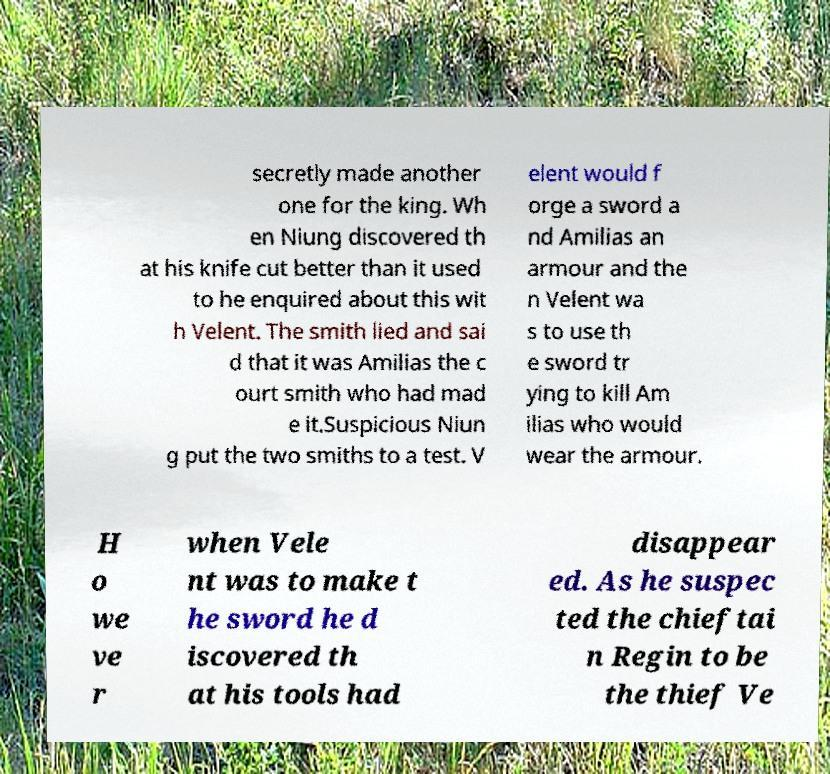Please read and relay the text visible in this image. What does it say? secretly made another one for the king. Wh en Niung discovered th at his knife cut better than it used to he enquired about this wit h Velent. The smith lied and sai d that it was Amilias the c ourt smith who had mad e it.Suspicious Niun g put the two smiths to a test. V elent would f orge a sword a nd Amilias an armour and the n Velent wa s to use th e sword tr ying to kill Am ilias who would wear the armour. H o we ve r when Vele nt was to make t he sword he d iscovered th at his tools had disappear ed. As he suspec ted the chieftai n Regin to be the thief Ve 